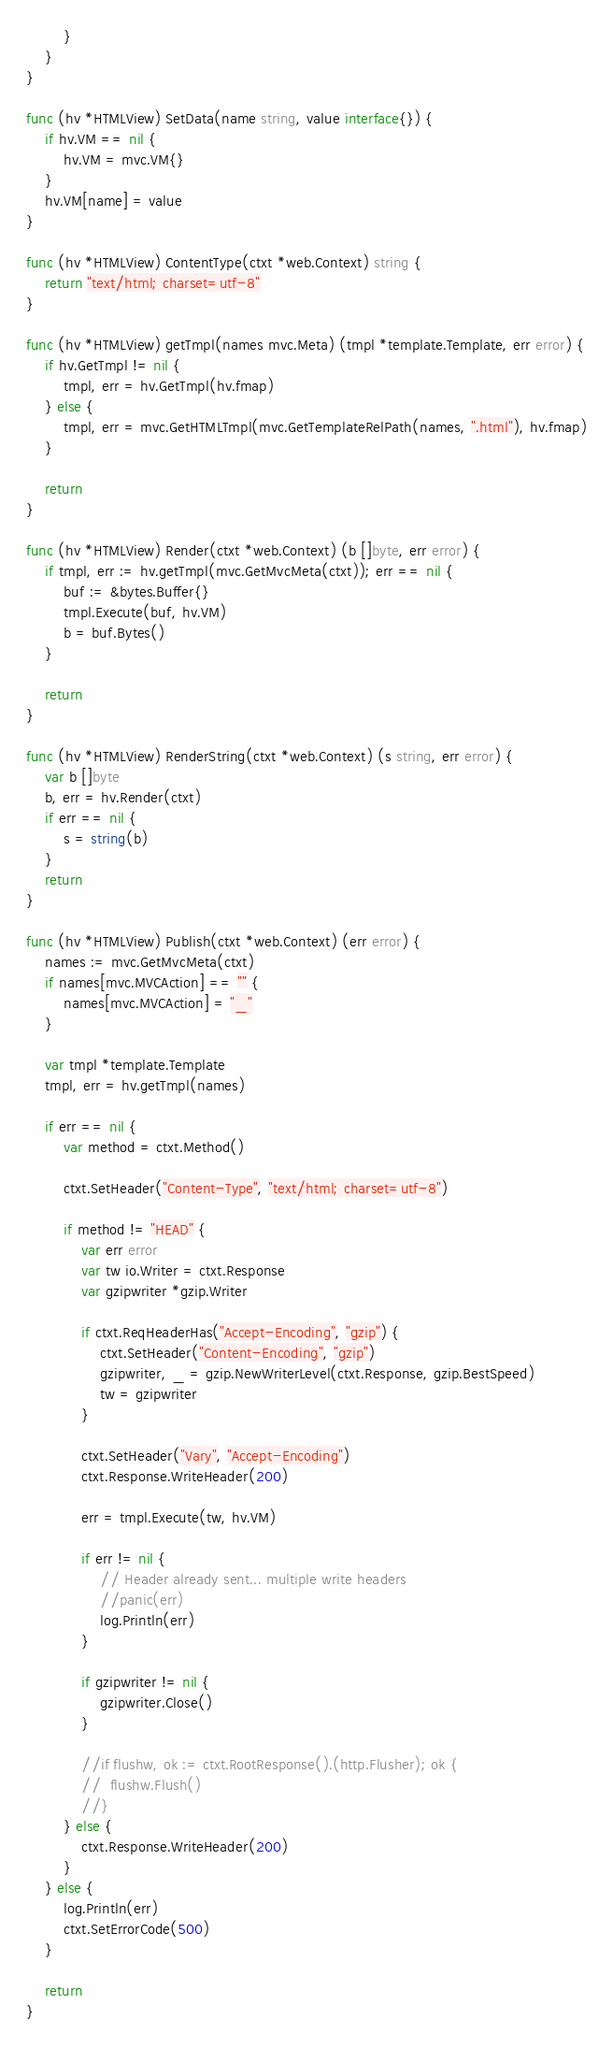Convert code to text. <code><loc_0><loc_0><loc_500><loc_500><_Go_>		}
	}
}

func (hv *HTMLView) SetData(name string, value interface{}) {
	if hv.VM == nil {
		hv.VM = mvc.VM{}
	}
	hv.VM[name] = value
}

func (hv *HTMLView) ContentType(ctxt *web.Context) string {
	return "text/html; charset=utf-8"
}

func (hv *HTMLView) getTmpl(names mvc.Meta) (tmpl *template.Template, err error) {
	if hv.GetTmpl != nil {
		tmpl, err = hv.GetTmpl(hv.fmap)
	} else {
		tmpl, err = mvc.GetHTMLTmpl(mvc.GetTemplateRelPath(names, ".html"), hv.fmap)
	}

	return
}

func (hv *HTMLView) Render(ctxt *web.Context) (b []byte, err error) {
	if tmpl, err := hv.getTmpl(mvc.GetMvcMeta(ctxt)); err == nil {
		buf := &bytes.Buffer{}
		tmpl.Execute(buf, hv.VM)
		b = buf.Bytes()
	}

	return
}

func (hv *HTMLView) RenderString(ctxt *web.Context) (s string, err error) {
	var b []byte
	b, err = hv.Render(ctxt)
	if err == nil {
		s = string(b)
	}
	return
}

func (hv *HTMLView) Publish(ctxt *web.Context) (err error) {
	names := mvc.GetMvcMeta(ctxt)
	if names[mvc.MVCAction] == "" {
		names[mvc.MVCAction] = "_"
	}

	var tmpl *template.Template
	tmpl, err = hv.getTmpl(names)

	if err == nil {
		var method = ctxt.Method()

		ctxt.SetHeader("Content-Type", "text/html; charset=utf-8")

		if method != "HEAD" {
			var err error
			var tw io.Writer = ctxt.Response
			var gzipwriter *gzip.Writer

			if ctxt.ReqHeaderHas("Accept-Encoding", "gzip") {
				ctxt.SetHeader("Content-Encoding", "gzip")
				gzipwriter, _ = gzip.NewWriterLevel(ctxt.Response, gzip.BestSpeed)
				tw = gzipwriter
			}

			ctxt.SetHeader("Vary", "Accept-Encoding")
			ctxt.Response.WriteHeader(200)

			err = tmpl.Execute(tw, hv.VM)

			if err != nil {
				// Header already sent... multiple write headers
				//panic(err)
				log.Println(err)
			}

			if gzipwriter != nil {
				gzipwriter.Close()
			}

			//if flushw, ok := ctxt.RootResponse().(http.Flusher); ok {
			//	flushw.Flush()
			//}
		} else {
			ctxt.Response.WriteHeader(200)
		}
	} else {
		log.Println(err)
		ctxt.SetErrorCode(500)
	}

	return
}
</code> 